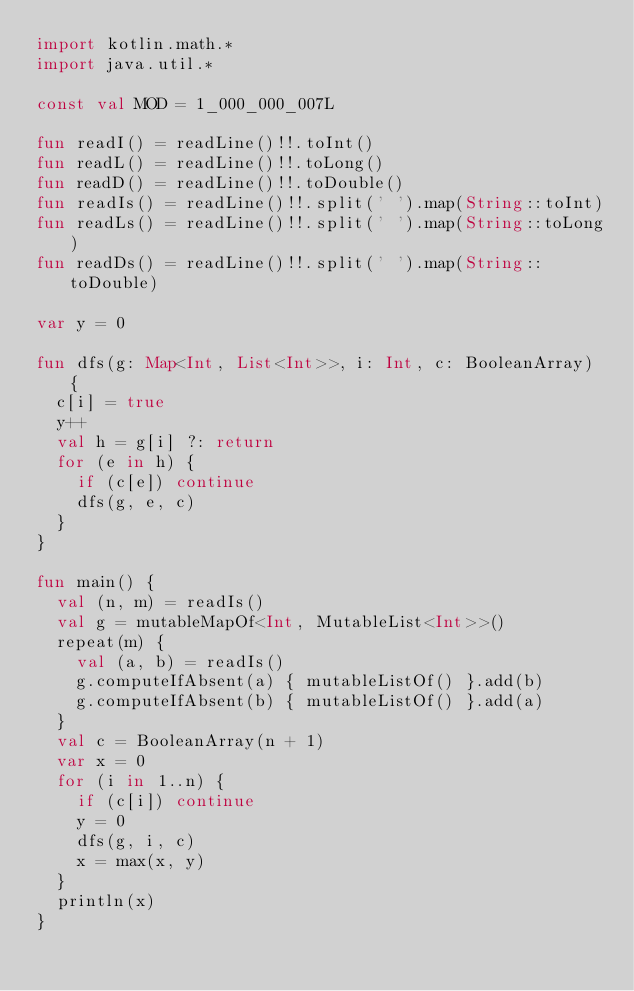Convert code to text. <code><loc_0><loc_0><loc_500><loc_500><_Kotlin_>import kotlin.math.*
import java.util.*

const val MOD = 1_000_000_007L

fun readI() = readLine()!!.toInt()
fun readL() = readLine()!!.toLong()
fun readD() = readLine()!!.toDouble()
fun readIs() = readLine()!!.split(' ').map(String::toInt)
fun readLs() = readLine()!!.split(' ').map(String::toLong)
fun readDs() = readLine()!!.split(' ').map(String::toDouble)

var y = 0

fun dfs(g: Map<Int, List<Int>>, i: Int, c: BooleanArray) {
  c[i] = true
  y++
  val h = g[i] ?: return
  for (e in h) {
    if (c[e]) continue
    dfs(g, e, c)
  }
}

fun main() {
  val (n, m) = readIs()
  val g = mutableMapOf<Int, MutableList<Int>>()
  repeat(m) {
    val (a, b) = readIs()
    g.computeIfAbsent(a) { mutableListOf() }.add(b)
    g.computeIfAbsent(b) { mutableListOf() }.add(a)
  }
  val c = BooleanArray(n + 1)
  var x = 0
  for (i in 1..n) {
    if (c[i]) continue
    y = 0
    dfs(g, i, c)
    x = max(x, y)
  }
  println(x)
}
</code> 